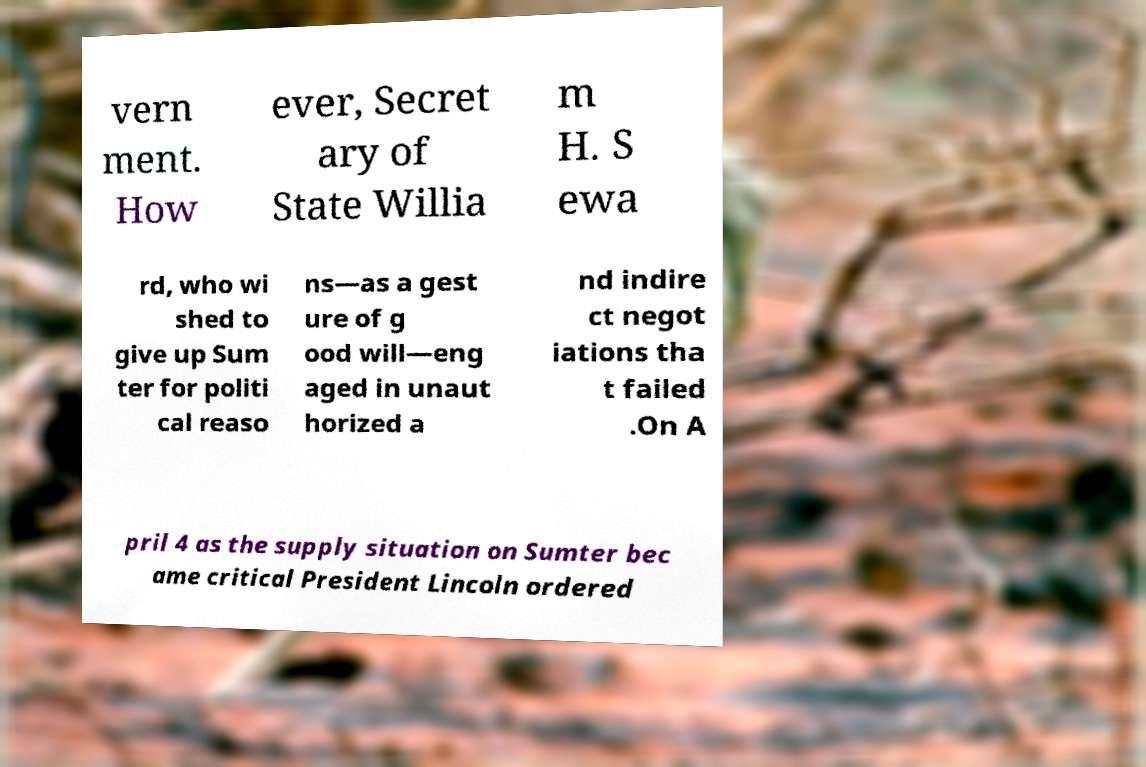Could you assist in decoding the text presented in this image and type it out clearly? vern ment. How ever, Secret ary of State Willia m H. S ewa rd, who wi shed to give up Sum ter for politi cal reaso ns—as a gest ure of g ood will—eng aged in unaut horized a nd indire ct negot iations tha t failed .On A pril 4 as the supply situation on Sumter bec ame critical President Lincoln ordered 